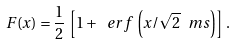Convert formula to latex. <formula><loc_0><loc_0><loc_500><loc_500>F ( x ) = \frac { 1 } { 2 } \, \left [ 1 + \ e r f \, \left ( x / \sqrt { 2 } \ m s \right ) \right ] \, .</formula> 